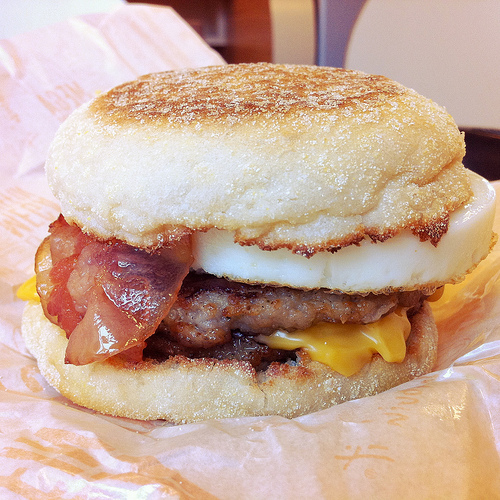<image>
Can you confirm if the egg is to the right of the bread? No. The egg is not to the right of the bread. The horizontal positioning shows a different relationship. Where is the egg in relation to the english muffin? Is it in the english muffin? Yes. The egg is contained within or inside the english muffin, showing a containment relationship. Is there a bacon next to the cheese? No. The bacon is not positioned next to the cheese. They are located in different areas of the scene. 